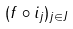<formula> <loc_0><loc_0><loc_500><loc_500>( f \circ i _ { j } ) _ { j \in J }</formula> 